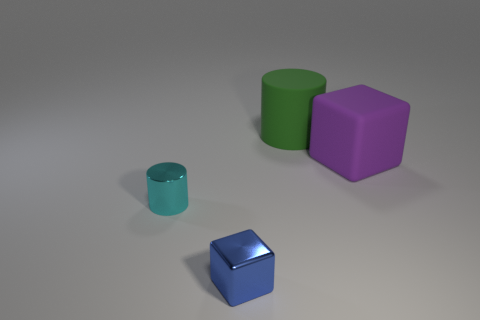The cube that is to the right of the blue metallic cube that is in front of the big thing that is on the left side of the purple matte object is what color?
Offer a terse response. Purple. Is the shape of the big purple thing the same as the tiny cyan metallic object?
Offer a terse response. No. What color is the big object that is made of the same material as the purple cube?
Offer a terse response. Green. How many things are rubber things behind the big purple cube or small red shiny things?
Offer a very short reply. 1. What size is the cube that is in front of the cyan thing?
Offer a very short reply. Small. Do the cyan object and the cube on the right side of the metallic block have the same size?
Your answer should be compact. No. What color is the cylinder in front of the rubber thing in front of the green cylinder?
Give a very brief answer. Cyan. How many other objects are the same color as the small metal cylinder?
Keep it short and to the point. 0. How big is the green rubber thing?
Offer a terse response. Large. Are there more purple objects that are in front of the blue shiny block than things that are in front of the large cube?
Your answer should be compact. No. 